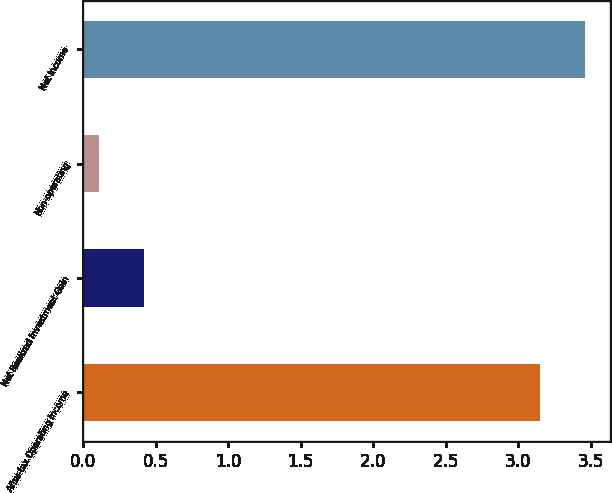<chart> <loc_0><loc_0><loc_500><loc_500><bar_chart><fcel>After-tax Operating Income<fcel>Net Realized Investment Gain<fcel>Non-operating<fcel>Net Income<nl><fcel>3.15<fcel>0.42<fcel>0.11<fcel>3.46<nl></chart> 